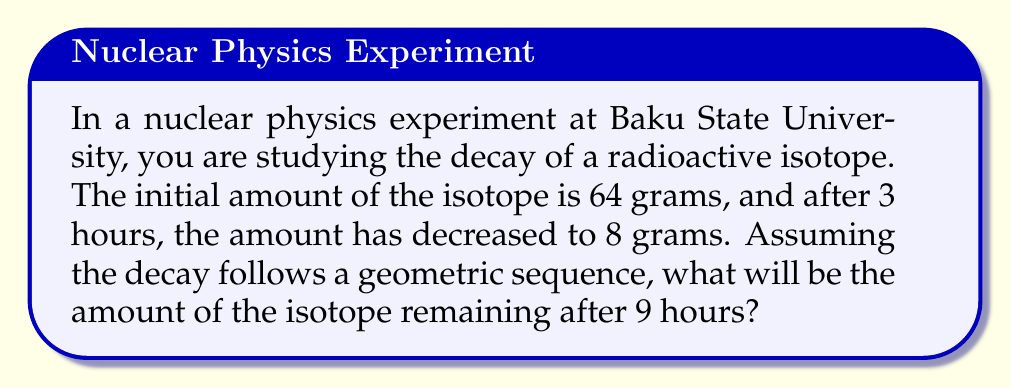Can you solve this math problem? Let's approach this step-by-step:

1) In a geometric sequence, each term is a constant multiple of the previous term. Let's call this constant $r$.

2) We know that:
   Initial amount: $a_0 = 64$ grams
   Amount after 3 hours: $a_3 = 8$ grams

3) The relationship between these terms is:
   $a_3 = a_0 \cdot r^3$

4) Substituting the known values:
   $8 = 64 \cdot r^3$

5) Solving for $r$:
   $$r^3 = \frac{8}{64} = \frac{1}{8}$$
   $$r = \sqrt[3]{\frac{1}{8}} = \frac{1}{2}$$

6) So, the amount decreases by half every hour.

7) To find the amount after 9 hours, we use:
   $a_9 = a_0 \cdot r^9$

8) Substituting the values:
   $$a_9 = 64 \cdot (\frac{1}{2})^9$$

9) Simplifying:
   $$a_9 = 64 \cdot \frac{1}{512} = \frac{1}{8} = 0.125$$

Therefore, after 9 hours, 0.125 grams of the isotope will remain.
Answer: 0.125 grams 